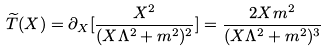<formula> <loc_0><loc_0><loc_500><loc_500>\widetilde { T } ( X ) = \partial _ { X } [ \frac { X ^ { 2 } } { ( X \Lambda ^ { 2 } + m ^ { 2 } ) ^ { 2 } } ] = \frac { 2 X m ^ { 2 } } { ( X \Lambda ^ { 2 } + m ^ { 2 } ) ^ { 3 } }</formula> 